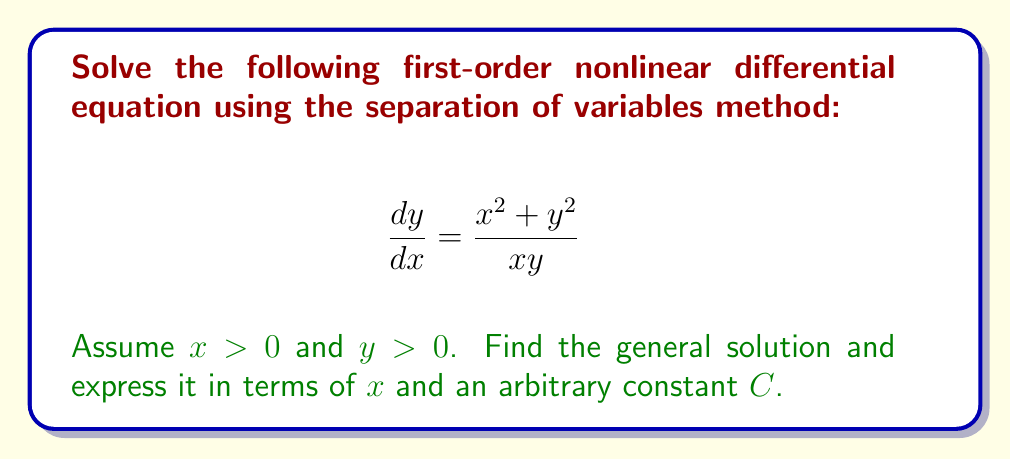Give your solution to this math problem. Let's solve this step-by-step using the separation of variables method:

1) First, we rearrange the equation to separate $x$ and $y$ terms:

   $$ \frac{y}{x^2 + y^2} dy = \frac{1}{x} dx $$

2) Now we integrate both sides:

   $$ \int \frac{y}{x^2 + y^2} dy = \int \frac{1}{x} dx $$

3) For the left side, we use the substitution $u = x^2 + y^2$. Then $du = 2y dy$, or $dy = \frac{du}{2y}$. Substituting:

   $$ \int \frac{1}{u} \cdot \frac{u-x^2}{u} \cdot \frac{du}{2} = \int \frac{1}{x} dx $$

4) Simplifying:

   $$ \frac{1}{2} \int \frac{u-x^2}{u^2} du = \int \frac{1}{x} dx $$

5) Integrating:

   $$ \frac{1}{2} \left(-\frac{1}{u} - \frac{x^2}{u} + C_1\right) = \ln|x| + C_2 $$

6) Substituting back $u = x^2 + y^2$:

   $$ -\frac{1}{2(x^2+y^2)} - \frac{x^2}{2(x^2+y^2)} = \ln|x| + C $$

   Where $C = C_2 - \frac{C_1}{2}$ is a new arbitrary constant.

7) Simplifying:

   $$ -\frac{1+x^2}{2(x^2+y^2)} = \ln|x| + C $$

8) Solving for $y^2$:

   $$ y^2 = \frac{1+x^2}{-2(\ln|x| + C)} - x^2 $$

9) Taking the square root (remember, we assumed $y > 0$):

   $$ y = \sqrt{\frac{1+x^2}{-2(\ln|x| + C)} - x^2} $$

This is the general solution to the differential equation.
Answer: $$ y = \sqrt{\frac{1+x^2}{-2(\ln|x| + C)} - x^2} $$
where $C$ is an arbitrary constant, $x > 0$, and $y > 0$. 